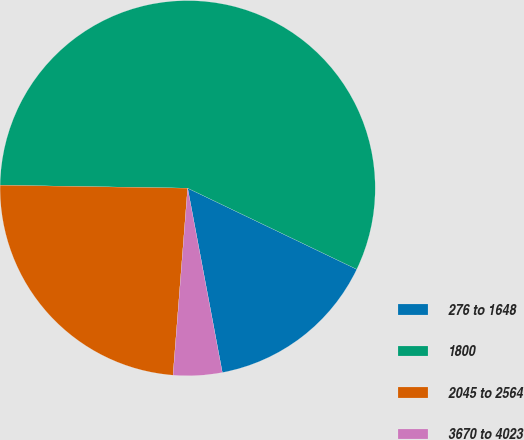<chart> <loc_0><loc_0><loc_500><loc_500><pie_chart><fcel>276 to 1648<fcel>1800<fcel>2045 to 2564<fcel>3670 to 4023<nl><fcel>14.92%<fcel>56.87%<fcel>24.01%<fcel>4.2%<nl></chart> 